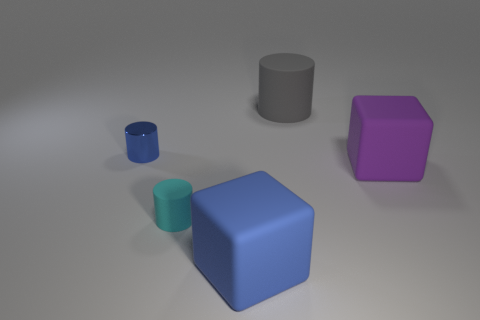What number of big blocks have the same color as the tiny shiny object?
Offer a terse response. 1. There is a small shiny thing; is its color the same as the matte object that is in front of the cyan rubber thing?
Your response must be concise. Yes. What shape is the cyan thing?
Offer a terse response. Cylinder. Is the number of tiny cyan matte cylinders that are to the right of the cyan rubber cylinder greater than the number of big matte objects that are behind the gray object?
Ensure brevity in your answer.  No. How many other objects are the same size as the cyan rubber thing?
Make the answer very short. 1. There is a object that is in front of the small metallic cylinder and right of the large blue thing; what is its material?
Provide a short and direct response. Rubber. There is another small thing that is the same shape as the small rubber object; what material is it?
Provide a succinct answer. Metal. There is a large object that is right of the object behind the blue shiny cylinder; how many small blue things are in front of it?
Give a very brief answer. 0. Are there any other things that have the same color as the metal cylinder?
Keep it short and to the point. Yes. What number of things are both to the right of the blue cylinder and left of the gray matte thing?
Ensure brevity in your answer.  2. 